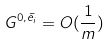Convert formula to latex. <formula><loc_0><loc_0><loc_500><loc_500>G ^ { 0 , \bar { e _ { i } } } = O ( \frac { 1 } { m } )</formula> 